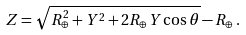<formula> <loc_0><loc_0><loc_500><loc_500>Z = \sqrt { R ^ { 2 } _ { \oplus } + Y ^ { 2 } + 2 R _ { \oplus } Y \cos \theta } - R _ { \oplus } \, .</formula> 